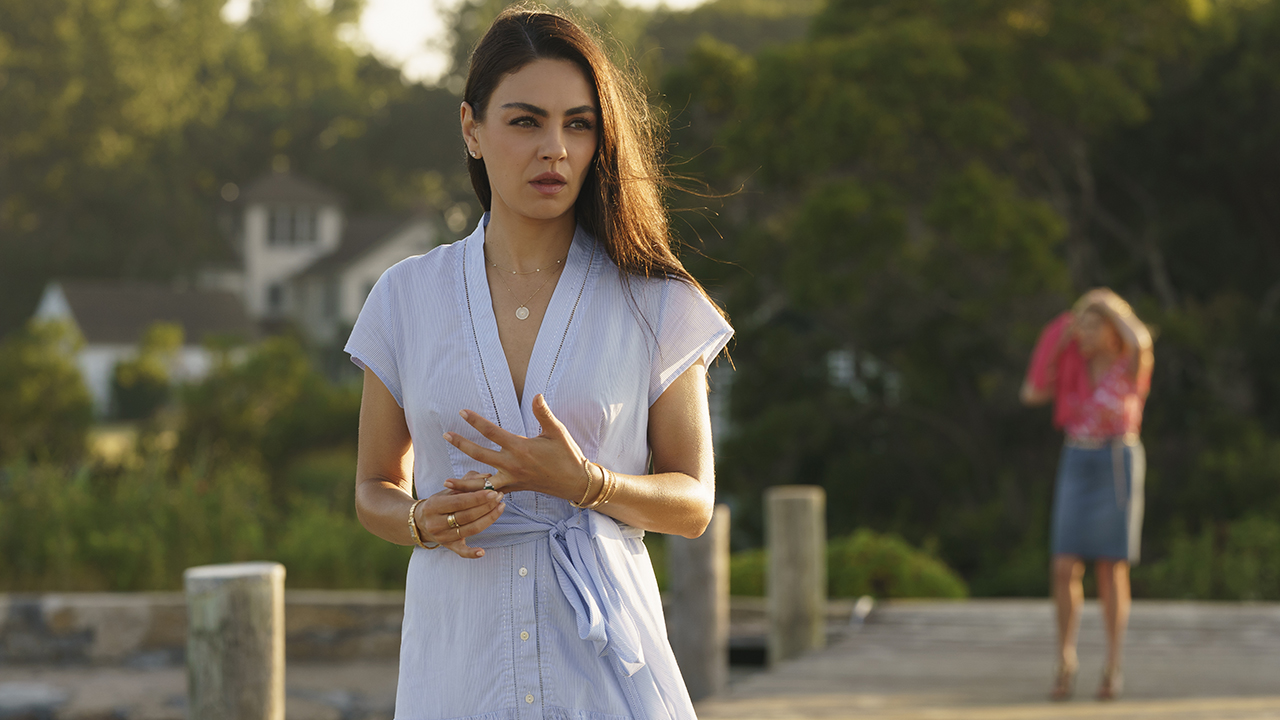If this scene were part of a movie, what genre might it belong to and why? This scene could belong to a drama or a romantic genre. The introspective and serene mood, combined with the contemplative expression of the woman in the foreground, suggests themes of personal growth, emotional depth, and possibly romance. The natural and tranquil setting by the water hints at a story that revolves around relationships, personal discovery, or transformative experiences. The presence of another woman in the background adds an element of narrative intrigue, making it suitable for a plot that explores complex human emotions and connections. Imagine a fantasy element suddenly appears in this scene. Describe how it changes. As the woman stands on the pier, lost in thought, the serene scene starts to shimmer with an ethereal glow. Suddenly, a luminescent mist begins to rise from the water, spiraling into the air and forming fantastical shapes. Out of the mist, a mythical creature emerges – perhaps a water dragon or a majestic phoenix – its presence both awe-inspiring and gentle. The creature approaches the woman, its eyes filled with ancient wisdom, and she reaches out, her fingers just grazing its shimmering form. The background shifts, the trees transforming into towering, glowing flora, and the house becomes a crystalline castle. The second woman, now aware of the fantastical events, turns around, her face alight with wonder. The scene becomes a blend of reality and fantasy, adding a magical element that suggests a journey into the unknown and mystical. 